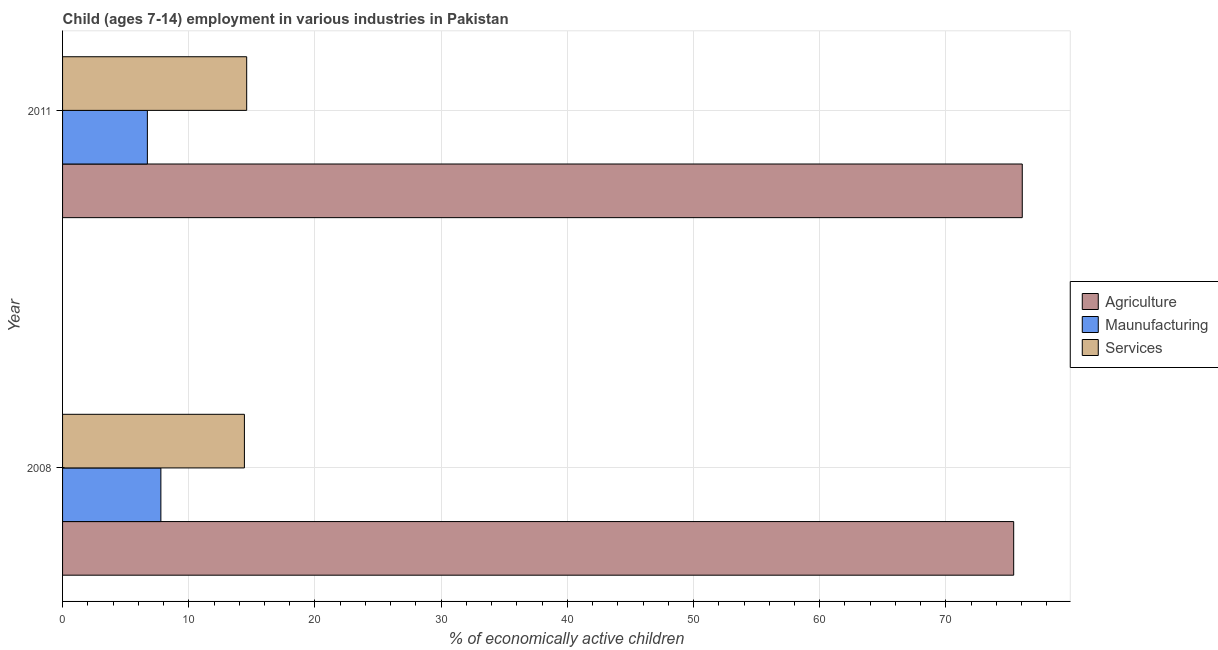How many groups of bars are there?
Your response must be concise. 2. How many bars are there on the 2nd tick from the top?
Make the answer very short. 3. How many bars are there on the 2nd tick from the bottom?
Keep it short and to the point. 3. In how many cases, is the number of bars for a given year not equal to the number of legend labels?
Give a very brief answer. 0. What is the percentage of economically active children in services in 2008?
Your answer should be compact. 14.41. Across all years, what is the maximum percentage of economically active children in agriculture?
Your answer should be compact. 76.05. Across all years, what is the minimum percentage of economically active children in agriculture?
Give a very brief answer. 75.37. In which year was the percentage of economically active children in agriculture maximum?
Your answer should be very brief. 2011. In which year was the percentage of economically active children in services minimum?
Ensure brevity in your answer.  2008. What is the total percentage of economically active children in agriculture in the graph?
Provide a short and direct response. 151.42. What is the difference between the percentage of economically active children in manufacturing in 2008 and that in 2011?
Your response must be concise. 1.07. What is the difference between the percentage of economically active children in services in 2008 and the percentage of economically active children in agriculture in 2011?
Your response must be concise. -61.64. What is the average percentage of economically active children in agriculture per year?
Your answer should be compact. 75.71. In the year 2008, what is the difference between the percentage of economically active children in manufacturing and percentage of economically active children in agriculture?
Offer a terse response. -67.58. What is the ratio of the percentage of economically active children in manufacturing in 2008 to that in 2011?
Make the answer very short. 1.16. Is the percentage of economically active children in manufacturing in 2008 less than that in 2011?
Provide a succinct answer. No. Is the difference between the percentage of economically active children in agriculture in 2008 and 2011 greater than the difference between the percentage of economically active children in services in 2008 and 2011?
Keep it short and to the point. No. In how many years, is the percentage of economically active children in services greater than the average percentage of economically active children in services taken over all years?
Provide a short and direct response. 1. What does the 2nd bar from the top in 2008 represents?
Your answer should be compact. Maunufacturing. What does the 2nd bar from the bottom in 2011 represents?
Make the answer very short. Maunufacturing. Is it the case that in every year, the sum of the percentage of economically active children in agriculture and percentage of economically active children in manufacturing is greater than the percentage of economically active children in services?
Ensure brevity in your answer.  Yes. How many bars are there?
Your answer should be very brief. 6. How many years are there in the graph?
Offer a very short reply. 2. What is the difference between two consecutive major ticks on the X-axis?
Give a very brief answer. 10. Where does the legend appear in the graph?
Your response must be concise. Center right. What is the title of the graph?
Your response must be concise. Child (ages 7-14) employment in various industries in Pakistan. What is the label or title of the X-axis?
Keep it short and to the point. % of economically active children. What is the label or title of the Y-axis?
Your answer should be compact. Year. What is the % of economically active children in Agriculture in 2008?
Your answer should be compact. 75.37. What is the % of economically active children in Maunufacturing in 2008?
Provide a short and direct response. 7.79. What is the % of economically active children in Services in 2008?
Offer a terse response. 14.41. What is the % of economically active children in Agriculture in 2011?
Ensure brevity in your answer.  76.05. What is the % of economically active children of Maunufacturing in 2011?
Ensure brevity in your answer.  6.72. What is the % of economically active children in Services in 2011?
Offer a terse response. 14.59. Across all years, what is the maximum % of economically active children of Agriculture?
Your answer should be very brief. 76.05. Across all years, what is the maximum % of economically active children in Maunufacturing?
Your response must be concise. 7.79. Across all years, what is the maximum % of economically active children in Services?
Your response must be concise. 14.59. Across all years, what is the minimum % of economically active children in Agriculture?
Provide a succinct answer. 75.37. Across all years, what is the minimum % of economically active children of Maunufacturing?
Offer a very short reply. 6.72. Across all years, what is the minimum % of economically active children of Services?
Your answer should be very brief. 14.41. What is the total % of economically active children in Agriculture in the graph?
Keep it short and to the point. 151.42. What is the total % of economically active children in Maunufacturing in the graph?
Give a very brief answer. 14.51. What is the difference between the % of economically active children in Agriculture in 2008 and that in 2011?
Give a very brief answer. -0.68. What is the difference between the % of economically active children in Maunufacturing in 2008 and that in 2011?
Provide a short and direct response. 1.07. What is the difference between the % of economically active children of Services in 2008 and that in 2011?
Provide a succinct answer. -0.18. What is the difference between the % of economically active children of Agriculture in 2008 and the % of economically active children of Maunufacturing in 2011?
Your response must be concise. 68.65. What is the difference between the % of economically active children in Agriculture in 2008 and the % of economically active children in Services in 2011?
Your answer should be compact. 60.78. What is the average % of economically active children in Agriculture per year?
Make the answer very short. 75.71. What is the average % of economically active children of Maunufacturing per year?
Keep it short and to the point. 7.25. What is the average % of economically active children of Services per year?
Provide a short and direct response. 14.5. In the year 2008, what is the difference between the % of economically active children in Agriculture and % of economically active children in Maunufacturing?
Ensure brevity in your answer.  67.58. In the year 2008, what is the difference between the % of economically active children of Agriculture and % of economically active children of Services?
Offer a terse response. 60.96. In the year 2008, what is the difference between the % of economically active children of Maunufacturing and % of economically active children of Services?
Give a very brief answer. -6.62. In the year 2011, what is the difference between the % of economically active children of Agriculture and % of economically active children of Maunufacturing?
Offer a terse response. 69.33. In the year 2011, what is the difference between the % of economically active children in Agriculture and % of economically active children in Services?
Provide a succinct answer. 61.46. In the year 2011, what is the difference between the % of economically active children in Maunufacturing and % of economically active children in Services?
Make the answer very short. -7.87. What is the ratio of the % of economically active children in Agriculture in 2008 to that in 2011?
Keep it short and to the point. 0.99. What is the ratio of the % of economically active children of Maunufacturing in 2008 to that in 2011?
Offer a terse response. 1.16. What is the difference between the highest and the second highest % of economically active children of Agriculture?
Ensure brevity in your answer.  0.68. What is the difference between the highest and the second highest % of economically active children in Maunufacturing?
Your answer should be compact. 1.07. What is the difference between the highest and the second highest % of economically active children in Services?
Provide a short and direct response. 0.18. What is the difference between the highest and the lowest % of economically active children of Agriculture?
Your answer should be compact. 0.68. What is the difference between the highest and the lowest % of economically active children in Maunufacturing?
Keep it short and to the point. 1.07. What is the difference between the highest and the lowest % of economically active children of Services?
Offer a very short reply. 0.18. 